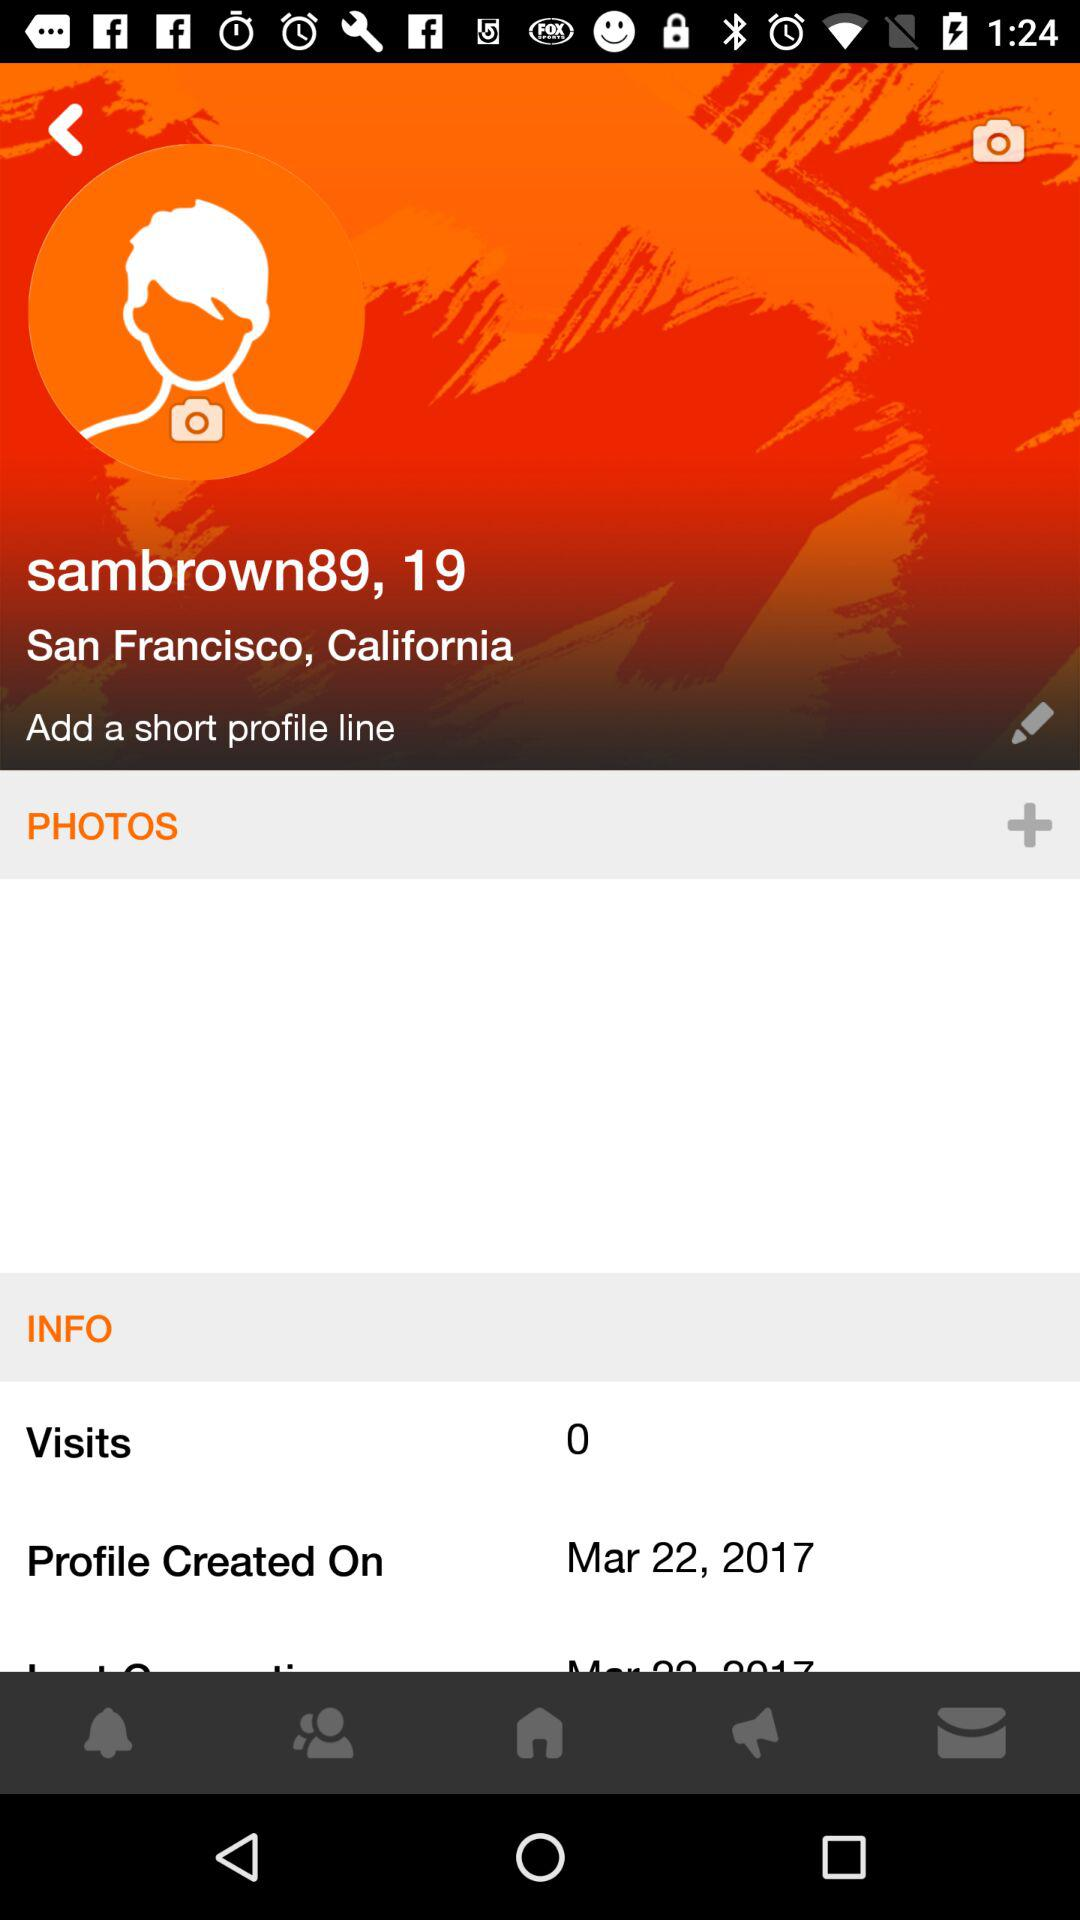What's the age of the user? The user's age is 19. 